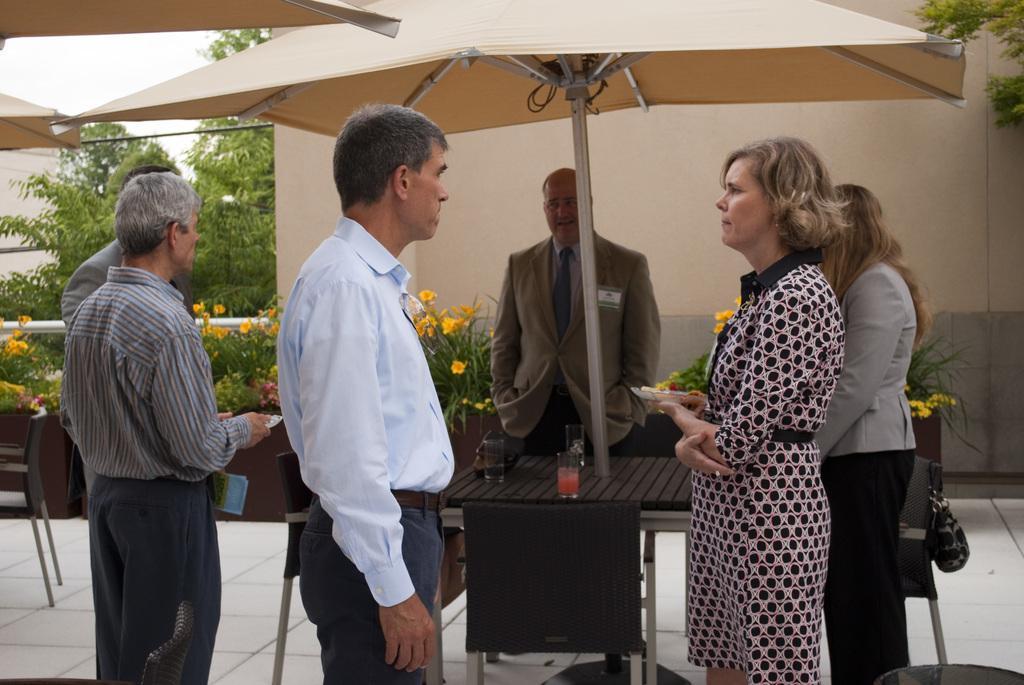Can you describe this image briefly? In the center of the image there are people standing. There is a table. There are chairs. In the background of the image there is a wall. There are trees. 